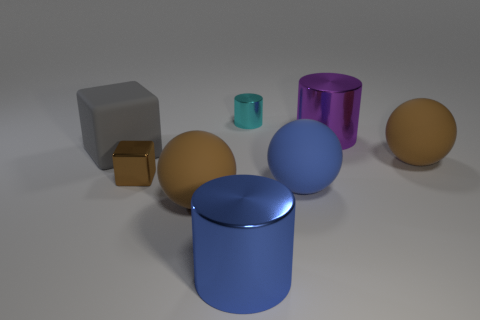What color is the rubber block?
Make the answer very short. Gray. There is a cylinder in front of the matte cube; how big is it?
Your answer should be compact. Large. How many brown objects are on the left side of the brown rubber thing right of the ball that is on the left side of the large blue matte ball?
Offer a terse response. 2. What color is the matte ball left of the small shiny thing that is behind the purple shiny cylinder?
Offer a very short reply. Brown. Are there any shiny things of the same size as the cyan shiny cylinder?
Keep it short and to the point. Yes. The brown sphere that is to the left of the brown ball on the right side of the cylinder that is in front of the big purple object is made of what material?
Your answer should be very brief. Rubber. There is a brown matte object to the right of the blue metallic cylinder; how many brown objects are in front of it?
Your answer should be very brief. 2. Is the size of the metal cylinder behind the purple object the same as the blue ball?
Offer a very short reply. No. How many large gray rubber things are the same shape as the small brown metal thing?
Provide a succinct answer. 1. What is the shape of the small brown object?
Offer a terse response. Cube. 